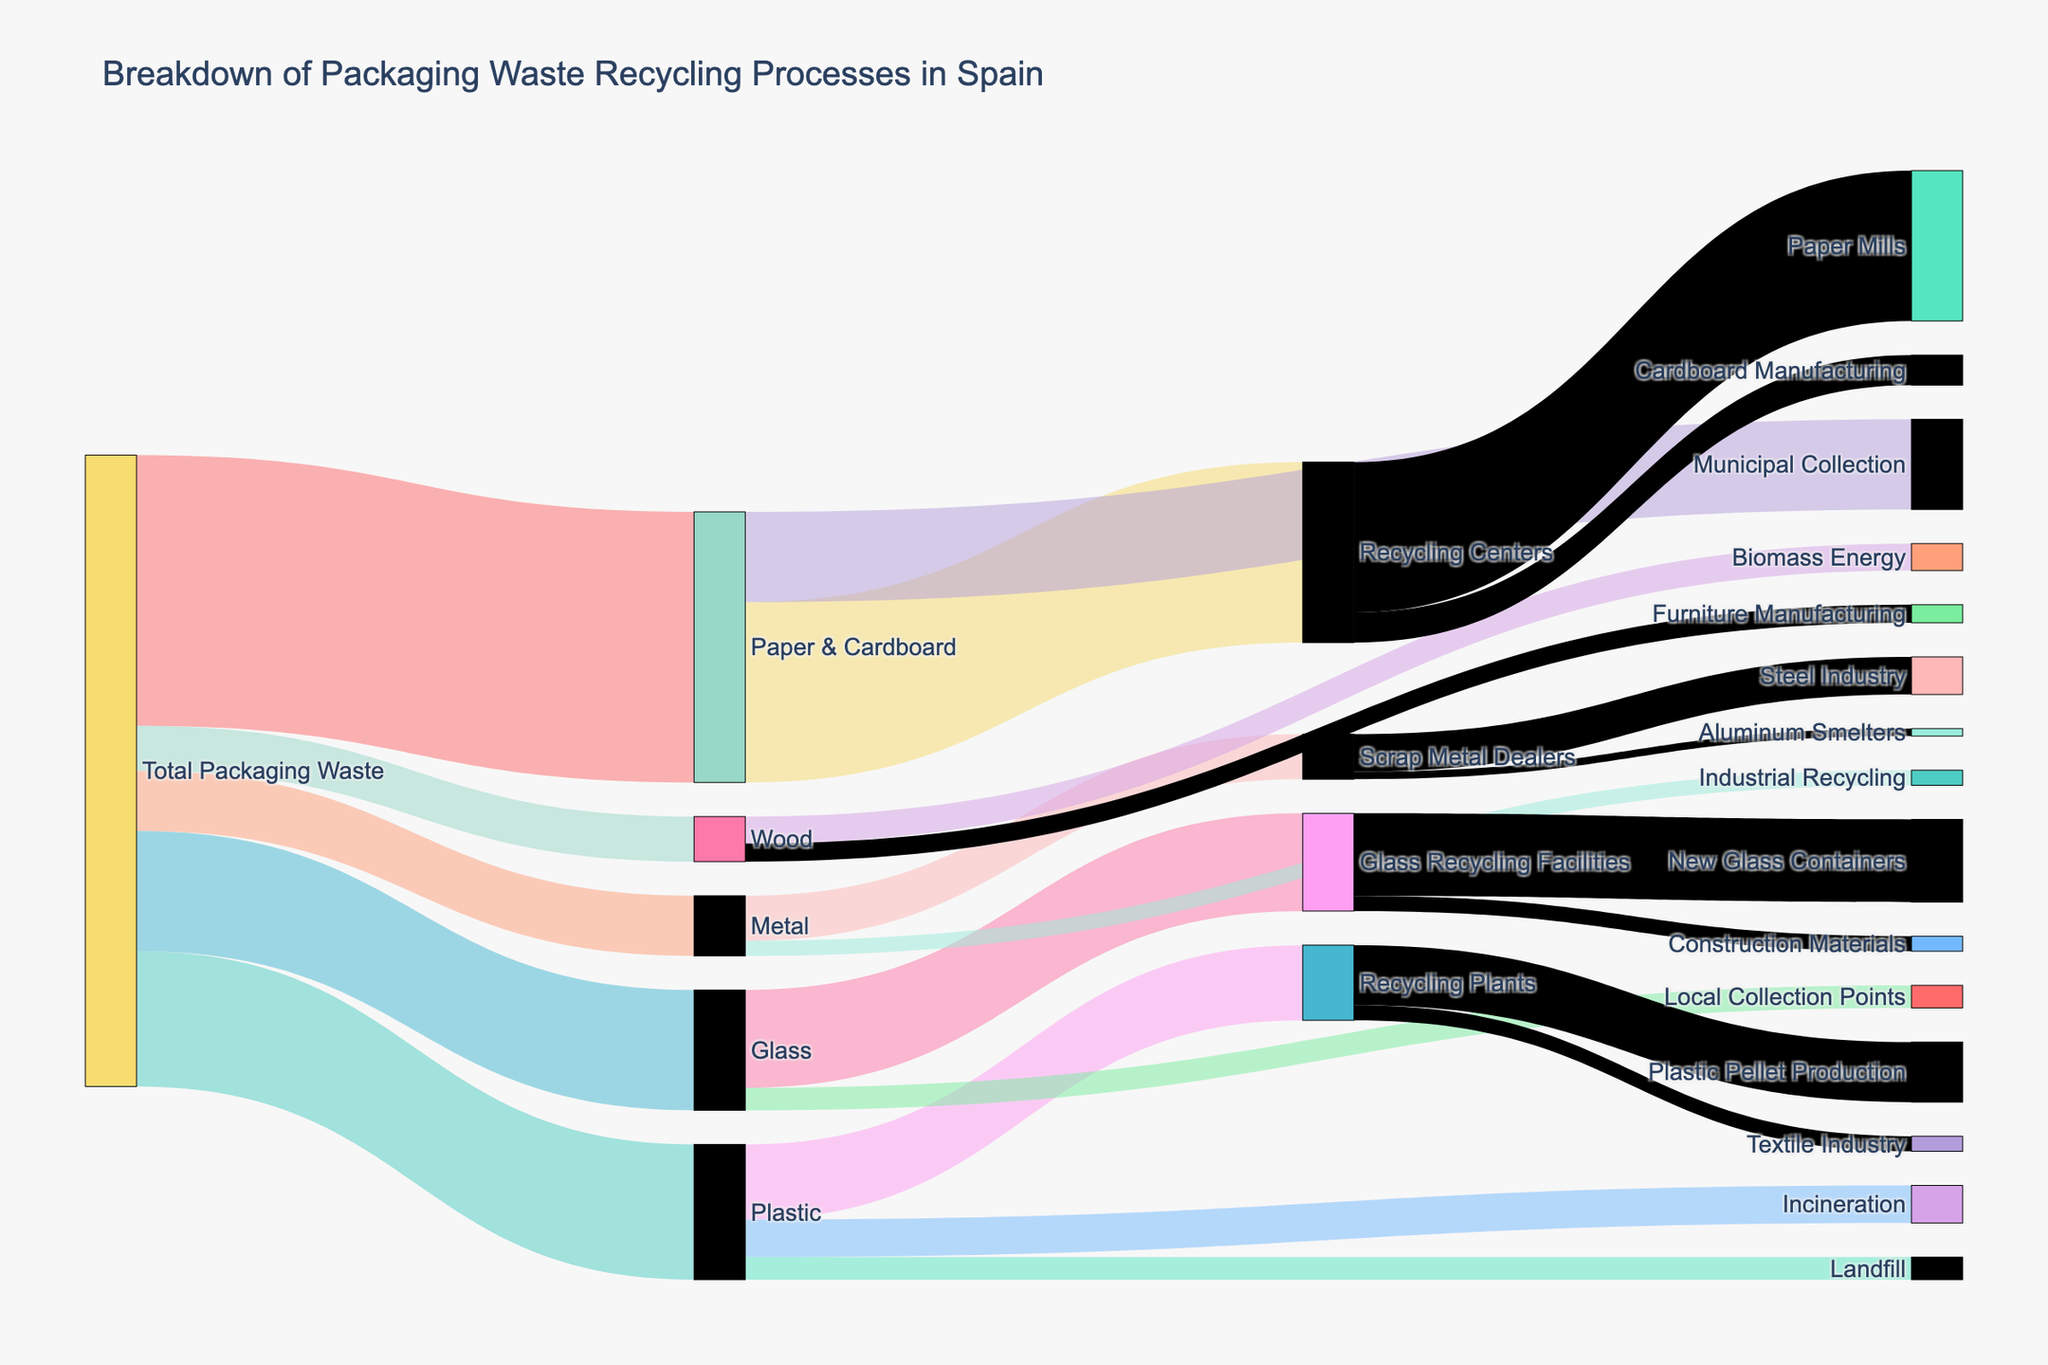what is the total amount of plastic waste? To find the total amount of plastic waste, look at the flow directly from "Total Packaging Waste" to "Plastic." The value associated with this flow is 900,000.
Answer: 900,000 Which type of waste has the least amount? Compare the values directly flowing out from "Total Packaging Waste" to each type of waste. The smallest value is associated with "Wood," which is 300,000.
Answer: Wood How much paper & cardboard waste goes to recycling centers? Identify the flow from "Paper & Cardboard" to "Recycling Centers." The value here is 1,200,000.
Answer: 1,200,000 What is the combined amount of wood waste used in biomass energy and furniture manufacturing? Add the values of wood waste going to "Biomass Energy" (180,000) and "Furniture Manufacturing" (120,000). The total is 180,000 + 120,000 = 300,000.
Answer: 300,000 How does the amount of plastic waste going to landfills compare to that going to incineration? Compare the values of plastic waste going to "Landfill" (150,000) and "Incineration" (250,000). The amount going to incineration is larger.
Answer: Incineration From the recycling centers, how much waste goes to paper mills? Look at the flow from "Recycling Centers" to "Paper Mills." The value is 1,000,000.
Answer: 1,000,000 What percentage of metal waste goes to scrap metal dealers? Calculate the percentage of the metal waste going to "Scrap Metal Dealers" out of the total metal waste. Total metal waste is 400,000, and the amount to scrap metal dealers is 300,000. The percentage is (300,000 / 400,000) * 100% = 75%.
Answer: 75% Which type of recycling plant receives the most plastic waste? Compare the values of plastic waste going to "Recycling Plants," "Incineration," and "Landfill." "Recycling Plants" receives the most with 500,000.
Answer: Recycling Plants What is the total amount of waste recycled into new glass containers? Look at the flow from "Glass Recycling Facilities" to "New Glass Containers." The value is 550,000.
Answer: 550,000 How much waste is processed for the steel industry? Identify the flow from "Scrap Metal Dealers" to "Steel Industry." The value here is 250,000.
Answer: 250,000 